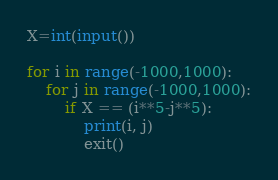<code> <loc_0><loc_0><loc_500><loc_500><_Python_>X=int(input())

for i in range(-1000,1000):
    for j in range(-1000,1000):
        if X == (i**5-j**5):
            print(i, j)
            exit()
</code> 